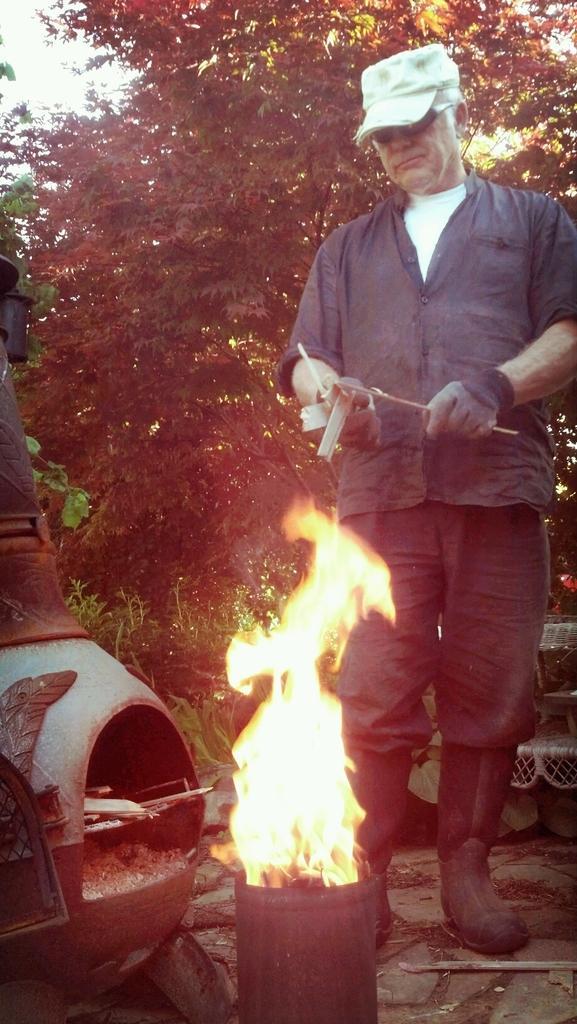Can you describe this image briefly? In this image I can see a man is standing and I can see he is wearing gloves, shirt, pant, shoes, shades and a cap. I can also see he is holding few things and in the front of him I can see fire and few stuffs. In the background I can see few trees. 